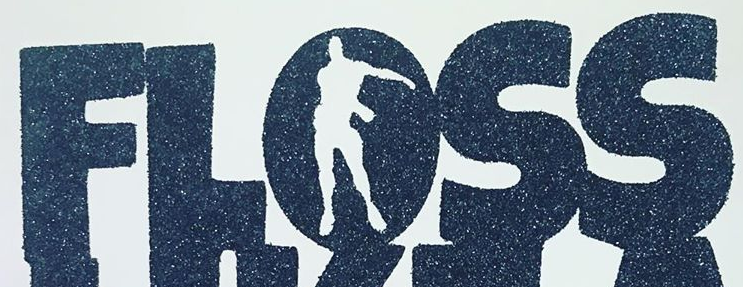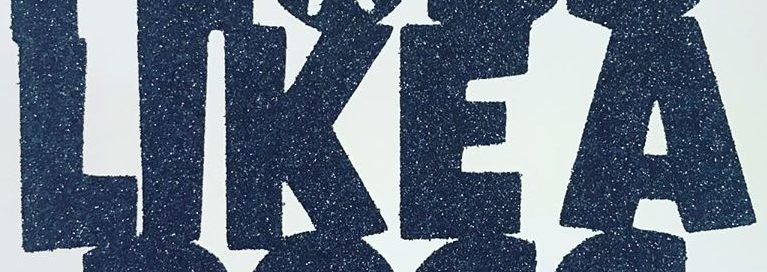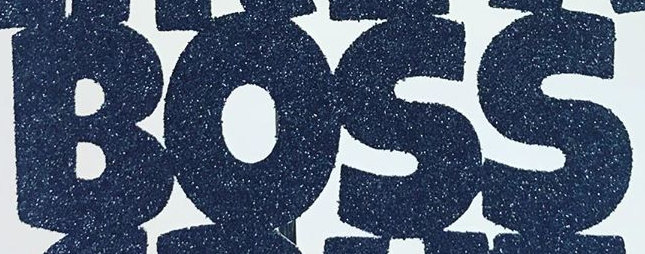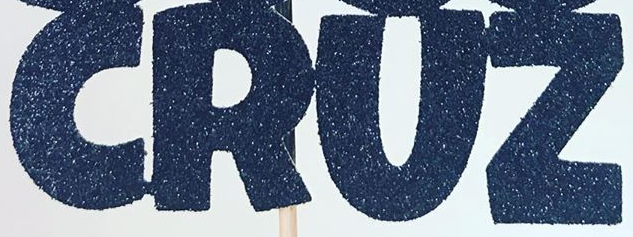Read the text content from these images in order, separated by a semicolon. FLOSS; LIKEA; BOSS; CRUZ 